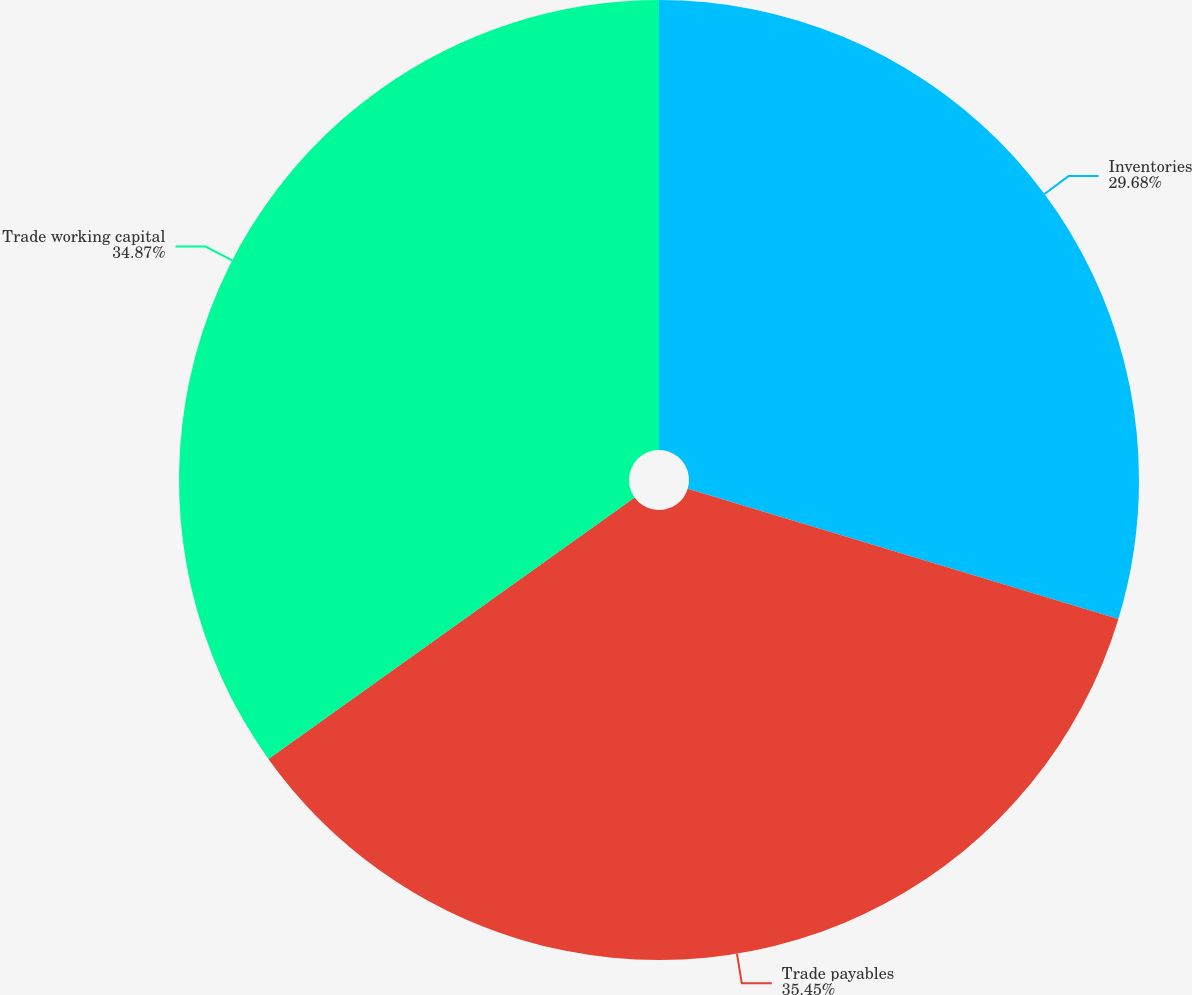<chart> <loc_0><loc_0><loc_500><loc_500><pie_chart><fcel>Inventories<fcel>Trade payables<fcel>Trade working capital<nl><fcel>29.68%<fcel>35.45%<fcel>34.87%<nl></chart> 